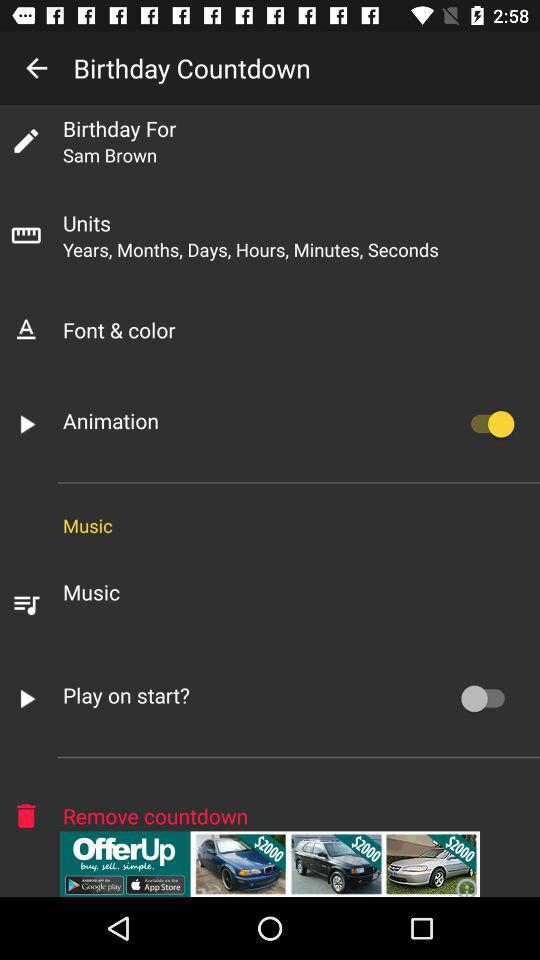What is the status of the "Animation"? The status is "on". 